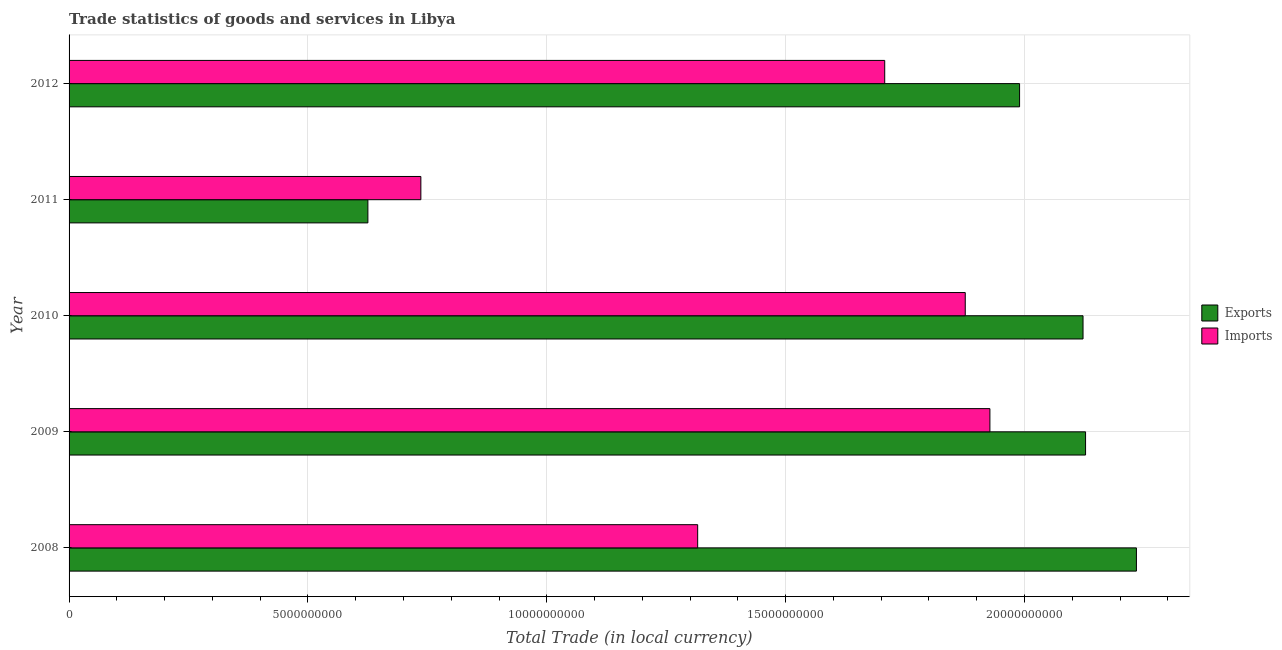How many bars are there on the 3rd tick from the bottom?
Keep it short and to the point. 2. What is the label of the 1st group of bars from the top?
Give a very brief answer. 2012. In how many cases, is the number of bars for a given year not equal to the number of legend labels?
Your answer should be very brief. 0. What is the export of goods and services in 2011?
Your answer should be compact. 6.25e+09. Across all years, what is the maximum export of goods and services?
Keep it short and to the point. 2.23e+1. Across all years, what is the minimum export of goods and services?
Offer a very short reply. 6.25e+09. In which year was the export of goods and services maximum?
Offer a terse response. 2008. In which year was the imports of goods and services minimum?
Provide a short and direct response. 2011. What is the total imports of goods and services in the graph?
Keep it short and to the point. 7.56e+1. What is the difference between the imports of goods and services in 2010 and that in 2011?
Offer a very short reply. 1.14e+1. What is the difference between the imports of goods and services in 2008 and the export of goods and services in 2010?
Make the answer very short. -8.07e+09. What is the average export of goods and services per year?
Provide a succinct answer. 1.82e+1. In the year 2008, what is the difference between the export of goods and services and imports of goods and services?
Give a very brief answer. 9.18e+09. In how many years, is the export of goods and services greater than 17000000000 LCU?
Offer a very short reply. 4. What is the ratio of the imports of goods and services in 2011 to that in 2012?
Offer a terse response. 0.43. Is the export of goods and services in 2008 less than that in 2011?
Give a very brief answer. No. What is the difference between the highest and the second highest imports of goods and services?
Offer a very short reply. 5.16e+08. What is the difference between the highest and the lowest imports of goods and services?
Give a very brief answer. 1.19e+1. What does the 2nd bar from the top in 2012 represents?
Offer a terse response. Exports. What does the 2nd bar from the bottom in 2008 represents?
Your answer should be very brief. Imports. How many years are there in the graph?
Give a very brief answer. 5. What is the difference between two consecutive major ticks on the X-axis?
Ensure brevity in your answer.  5.00e+09. Are the values on the major ticks of X-axis written in scientific E-notation?
Give a very brief answer. No. Does the graph contain any zero values?
Offer a very short reply. No. Does the graph contain grids?
Offer a very short reply. Yes. How many legend labels are there?
Your answer should be very brief. 2. How are the legend labels stacked?
Ensure brevity in your answer.  Vertical. What is the title of the graph?
Provide a short and direct response. Trade statistics of goods and services in Libya. What is the label or title of the X-axis?
Ensure brevity in your answer.  Total Trade (in local currency). What is the Total Trade (in local currency) in Exports in 2008?
Provide a short and direct response. 2.23e+1. What is the Total Trade (in local currency) in Imports in 2008?
Ensure brevity in your answer.  1.32e+1. What is the Total Trade (in local currency) in Exports in 2009?
Make the answer very short. 2.13e+1. What is the Total Trade (in local currency) of Imports in 2009?
Your response must be concise. 1.93e+1. What is the Total Trade (in local currency) in Exports in 2010?
Your answer should be very brief. 2.12e+1. What is the Total Trade (in local currency) of Imports in 2010?
Ensure brevity in your answer.  1.88e+1. What is the Total Trade (in local currency) in Exports in 2011?
Your response must be concise. 6.25e+09. What is the Total Trade (in local currency) of Imports in 2011?
Offer a terse response. 7.36e+09. What is the Total Trade (in local currency) in Exports in 2012?
Keep it short and to the point. 1.99e+1. What is the Total Trade (in local currency) in Imports in 2012?
Keep it short and to the point. 1.71e+1. Across all years, what is the maximum Total Trade (in local currency) in Exports?
Offer a terse response. 2.23e+1. Across all years, what is the maximum Total Trade (in local currency) of Imports?
Your answer should be compact. 1.93e+1. Across all years, what is the minimum Total Trade (in local currency) of Exports?
Provide a succinct answer. 6.25e+09. Across all years, what is the minimum Total Trade (in local currency) of Imports?
Your response must be concise. 7.36e+09. What is the total Total Trade (in local currency) in Exports in the graph?
Ensure brevity in your answer.  9.10e+1. What is the total Total Trade (in local currency) in Imports in the graph?
Your answer should be very brief. 7.56e+1. What is the difference between the Total Trade (in local currency) of Exports in 2008 and that in 2009?
Ensure brevity in your answer.  1.06e+09. What is the difference between the Total Trade (in local currency) of Imports in 2008 and that in 2009?
Your answer should be very brief. -6.12e+09. What is the difference between the Total Trade (in local currency) in Exports in 2008 and that in 2010?
Your response must be concise. 1.12e+09. What is the difference between the Total Trade (in local currency) in Imports in 2008 and that in 2010?
Provide a short and direct response. -5.60e+09. What is the difference between the Total Trade (in local currency) in Exports in 2008 and that in 2011?
Give a very brief answer. 1.61e+1. What is the difference between the Total Trade (in local currency) of Imports in 2008 and that in 2011?
Offer a terse response. 5.79e+09. What is the difference between the Total Trade (in local currency) in Exports in 2008 and that in 2012?
Offer a terse response. 2.45e+09. What is the difference between the Total Trade (in local currency) in Imports in 2008 and that in 2012?
Your response must be concise. -3.92e+09. What is the difference between the Total Trade (in local currency) in Exports in 2009 and that in 2010?
Give a very brief answer. 5.28e+07. What is the difference between the Total Trade (in local currency) of Imports in 2009 and that in 2010?
Give a very brief answer. 5.16e+08. What is the difference between the Total Trade (in local currency) of Exports in 2009 and that in 2011?
Offer a terse response. 1.50e+1. What is the difference between the Total Trade (in local currency) of Imports in 2009 and that in 2011?
Ensure brevity in your answer.  1.19e+1. What is the difference between the Total Trade (in local currency) in Exports in 2009 and that in 2012?
Your answer should be compact. 1.38e+09. What is the difference between the Total Trade (in local currency) of Imports in 2009 and that in 2012?
Ensure brevity in your answer.  2.20e+09. What is the difference between the Total Trade (in local currency) of Exports in 2010 and that in 2011?
Keep it short and to the point. 1.50e+1. What is the difference between the Total Trade (in local currency) of Imports in 2010 and that in 2011?
Your answer should be very brief. 1.14e+1. What is the difference between the Total Trade (in local currency) of Exports in 2010 and that in 2012?
Give a very brief answer. 1.33e+09. What is the difference between the Total Trade (in local currency) of Imports in 2010 and that in 2012?
Give a very brief answer. 1.69e+09. What is the difference between the Total Trade (in local currency) of Exports in 2011 and that in 2012?
Offer a very short reply. -1.36e+1. What is the difference between the Total Trade (in local currency) in Imports in 2011 and that in 2012?
Provide a short and direct response. -9.71e+09. What is the difference between the Total Trade (in local currency) in Exports in 2008 and the Total Trade (in local currency) in Imports in 2009?
Provide a short and direct response. 3.07e+09. What is the difference between the Total Trade (in local currency) in Exports in 2008 and the Total Trade (in local currency) in Imports in 2010?
Give a very brief answer. 3.58e+09. What is the difference between the Total Trade (in local currency) of Exports in 2008 and the Total Trade (in local currency) of Imports in 2011?
Your answer should be compact. 1.50e+1. What is the difference between the Total Trade (in local currency) in Exports in 2008 and the Total Trade (in local currency) in Imports in 2012?
Offer a terse response. 5.27e+09. What is the difference between the Total Trade (in local currency) in Exports in 2009 and the Total Trade (in local currency) in Imports in 2010?
Give a very brief answer. 2.52e+09. What is the difference between the Total Trade (in local currency) of Exports in 2009 and the Total Trade (in local currency) of Imports in 2011?
Your response must be concise. 1.39e+1. What is the difference between the Total Trade (in local currency) in Exports in 2009 and the Total Trade (in local currency) in Imports in 2012?
Provide a succinct answer. 4.20e+09. What is the difference between the Total Trade (in local currency) in Exports in 2010 and the Total Trade (in local currency) in Imports in 2011?
Offer a very short reply. 1.39e+1. What is the difference between the Total Trade (in local currency) of Exports in 2010 and the Total Trade (in local currency) of Imports in 2012?
Keep it short and to the point. 4.15e+09. What is the difference between the Total Trade (in local currency) of Exports in 2011 and the Total Trade (in local currency) of Imports in 2012?
Provide a succinct answer. -1.08e+1. What is the average Total Trade (in local currency) in Exports per year?
Your answer should be very brief. 1.82e+1. What is the average Total Trade (in local currency) in Imports per year?
Provide a succinct answer. 1.51e+1. In the year 2008, what is the difference between the Total Trade (in local currency) in Exports and Total Trade (in local currency) in Imports?
Provide a short and direct response. 9.18e+09. In the year 2009, what is the difference between the Total Trade (in local currency) of Exports and Total Trade (in local currency) of Imports?
Make the answer very short. 2.00e+09. In the year 2010, what is the difference between the Total Trade (in local currency) in Exports and Total Trade (in local currency) in Imports?
Offer a terse response. 2.47e+09. In the year 2011, what is the difference between the Total Trade (in local currency) in Exports and Total Trade (in local currency) in Imports?
Provide a succinct answer. -1.11e+09. In the year 2012, what is the difference between the Total Trade (in local currency) of Exports and Total Trade (in local currency) of Imports?
Make the answer very short. 2.82e+09. What is the ratio of the Total Trade (in local currency) of Exports in 2008 to that in 2009?
Keep it short and to the point. 1.05. What is the ratio of the Total Trade (in local currency) of Imports in 2008 to that in 2009?
Your response must be concise. 0.68. What is the ratio of the Total Trade (in local currency) of Exports in 2008 to that in 2010?
Provide a succinct answer. 1.05. What is the ratio of the Total Trade (in local currency) of Imports in 2008 to that in 2010?
Offer a very short reply. 0.7. What is the ratio of the Total Trade (in local currency) of Exports in 2008 to that in 2011?
Provide a succinct answer. 3.57. What is the ratio of the Total Trade (in local currency) of Imports in 2008 to that in 2011?
Make the answer very short. 1.79. What is the ratio of the Total Trade (in local currency) of Exports in 2008 to that in 2012?
Your response must be concise. 1.12. What is the ratio of the Total Trade (in local currency) of Imports in 2008 to that in 2012?
Your answer should be very brief. 0.77. What is the ratio of the Total Trade (in local currency) of Exports in 2009 to that in 2010?
Offer a very short reply. 1. What is the ratio of the Total Trade (in local currency) in Imports in 2009 to that in 2010?
Your response must be concise. 1.03. What is the ratio of the Total Trade (in local currency) of Exports in 2009 to that in 2011?
Give a very brief answer. 3.4. What is the ratio of the Total Trade (in local currency) of Imports in 2009 to that in 2011?
Your answer should be very brief. 2.62. What is the ratio of the Total Trade (in local currency) of Exports in 2009 to that in 2012?
Offer a very short reply. 1.07. What is the ratio of the Total Trade (in local currency) of Imports in 2009 to that in 2012?
Give a very brief answer. 1.13. What is the ratio of the Total Trade (in local currency) of Exports in 2010 to that in 2011?
Offer a very short reply. 3.39. What is the ratio of the Total Trade (in local currency) in Imports in 2010 to that in 2011?
Offer a very short reply. 2.55. What is the ratio of the Total Trade (in local currency) in Exports in 2010 to that in 2012?
Give a very brief answer. 1.07. What is the ratio of the Total Trade (in local currency) in Imports in 2010 to that in 2012?
Your answer should be very brief. 1.1. What is the ratio of the Total Trade (in local currency) of Exports in 2011 to that in 2012?
Your answer should be very brief. 0.31. What is the ratio of the Total Trade (in local currency) in Imports in 2011 to that in 2012?
Offer a terse response. 0.43. What is the difference between the highest and the second highest Total Trade (in local currency) in Exports?
Make the answer very short. 1.06e+09. What is the difference between the highest and the second highest Total Trade (in local currency) of Imports?
Make the answer very short. 5.16e+08. What is the difference between the highest and the lowest Total Trade (in local currency) in Exports?
Your response must be concise. 1.61e+1. What is the difference between the highest and the lowest Total Trade (in local currency) of Imports?
Offer a terse response. 1.19e+1. 